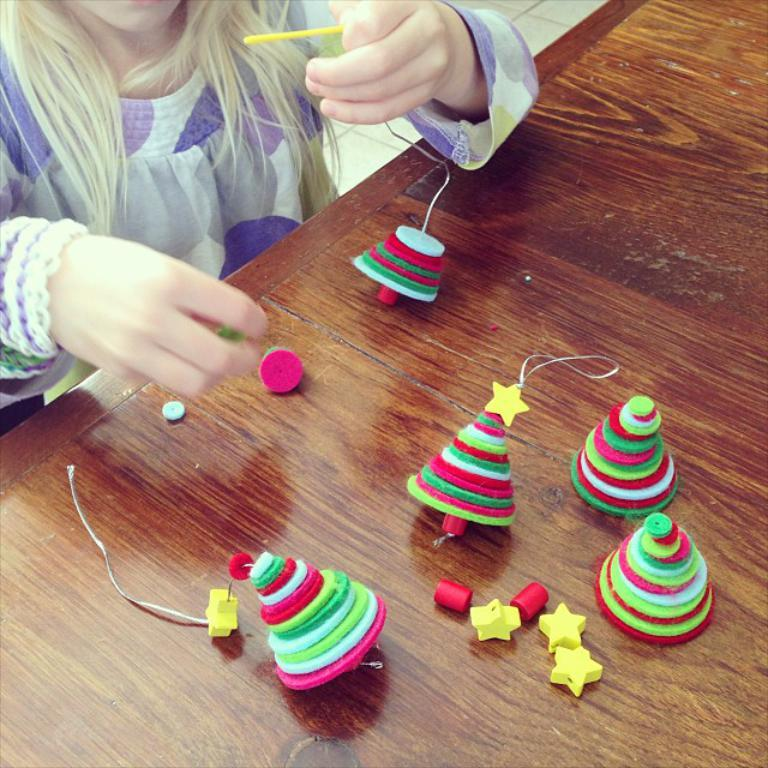Where is the person located in the image? The person is in the left top corner of the image. What is in front of the person? There is a table in front of the person. What can be seen on the table? There are objects of different colors on the table. What type of science experiment is being conducted on the table in the image? There is no indication of a science experiment or any scientific activity in the image. 